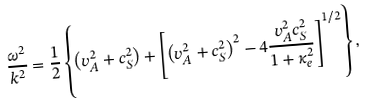Convert formula to latex. <formula><loc_0><loc_0><loc_500><loc_500>\frac { \omega ^ { 2 } } { k ^ { 2 } } = \frac { 1 } { 2 } \left \{ \left ( v _ { A } ^ { 2 } + c _ { S } ^ { 2 } \right ) + \left [ \left ( v _ { A } ^ { 2 } + c _ { S } ^ { 2 } \right ) ^ { 2 } - 4 \frac { v _ { A } ^ { 2 } c _ { S } ^ { 2 } } { 1 + \kappa _ { e } ^ { 2 } } \right ] ^ { 1 / 2 } \right \} ,</formula> 